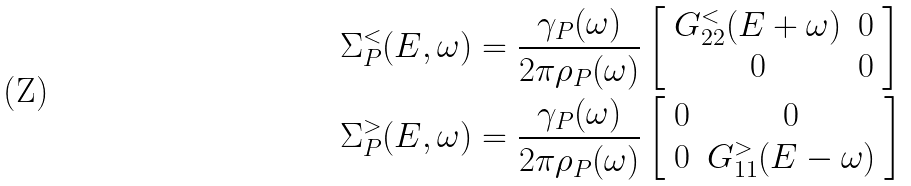<formula> <loc_0><loc_0><loc_500><loc_500>& \Sigma _ { P } ^ { < } ( E , \omega ) = \frac { \gamma _ { P } ( \omega ) } { 2 \pi \rho _ { P } ( \omega ) } \left [ \begin{array} { c c } G _ { 2 2 } ^ { < } ( E + \omega ) & 0 \\ 0 & 0 \end{array} \right ] \\ & \Sigma _ { P } ^ { > } ( E , \omega ) = \frac { \gamma _ { P } ( \omega ) } { 2 \pi \rho _ { P } ( \omega ) } \left [ \begin{array} { c c } 0 & 0 \\ 0 & G _ { 1 1 } ^ { > } ( E - \omega ) \end{array} \right ]</formula> 